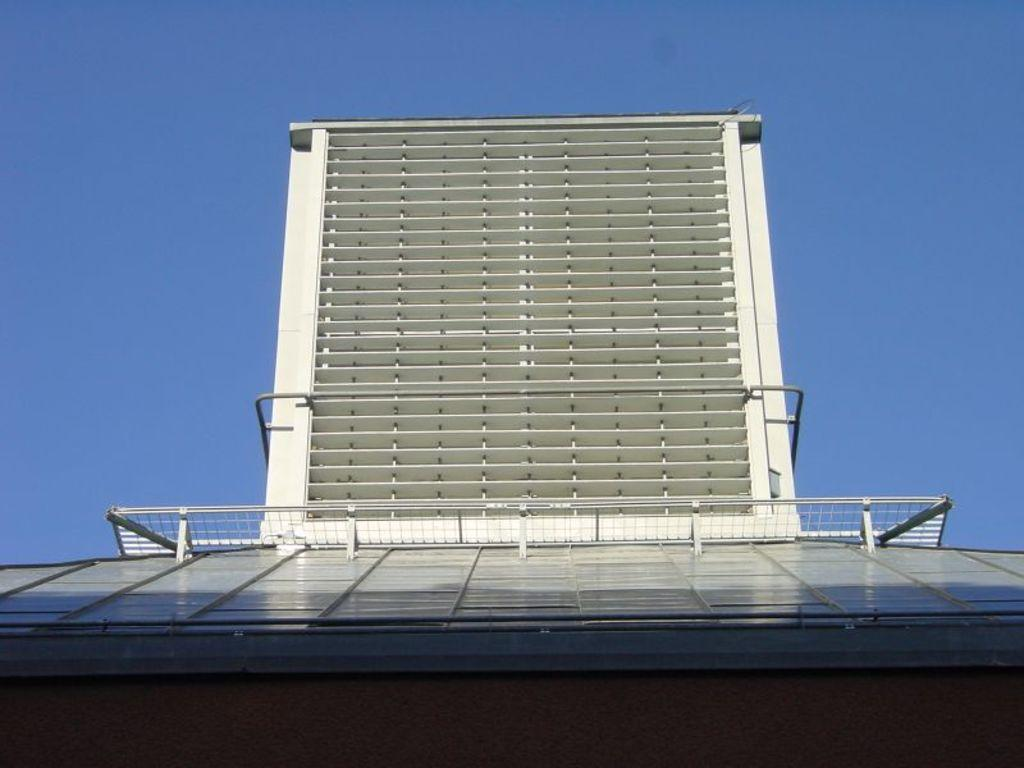What is located in the foreground of the image? There is a building and railing in the foreground of the image. Can you describe the sky in the image? The sky is clear in the image. What is the weather like in the image? The conditions in the image are sunny. What type of drain can be seen in the image? There is no drain present in the image. What type of field is visible in the image? There is no field visible in the image. 